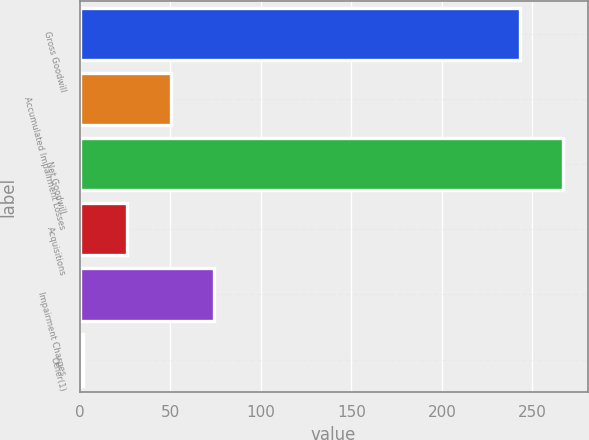<chart> <loc_0><loc_0><loc_500><loc_500><bar_chart><fcel>Gross Goodwill<fcel>Accumulated Impairment Losses<fcel>Net Goodwill<fcel>Acquisitions<fcel>Impairment Charges<fcel>Other(1)<nl><fcel>243<fcel>50.2<fcel>267.1<fcel>26.1<fcel>74.3<fcel>2<nl></chart> 